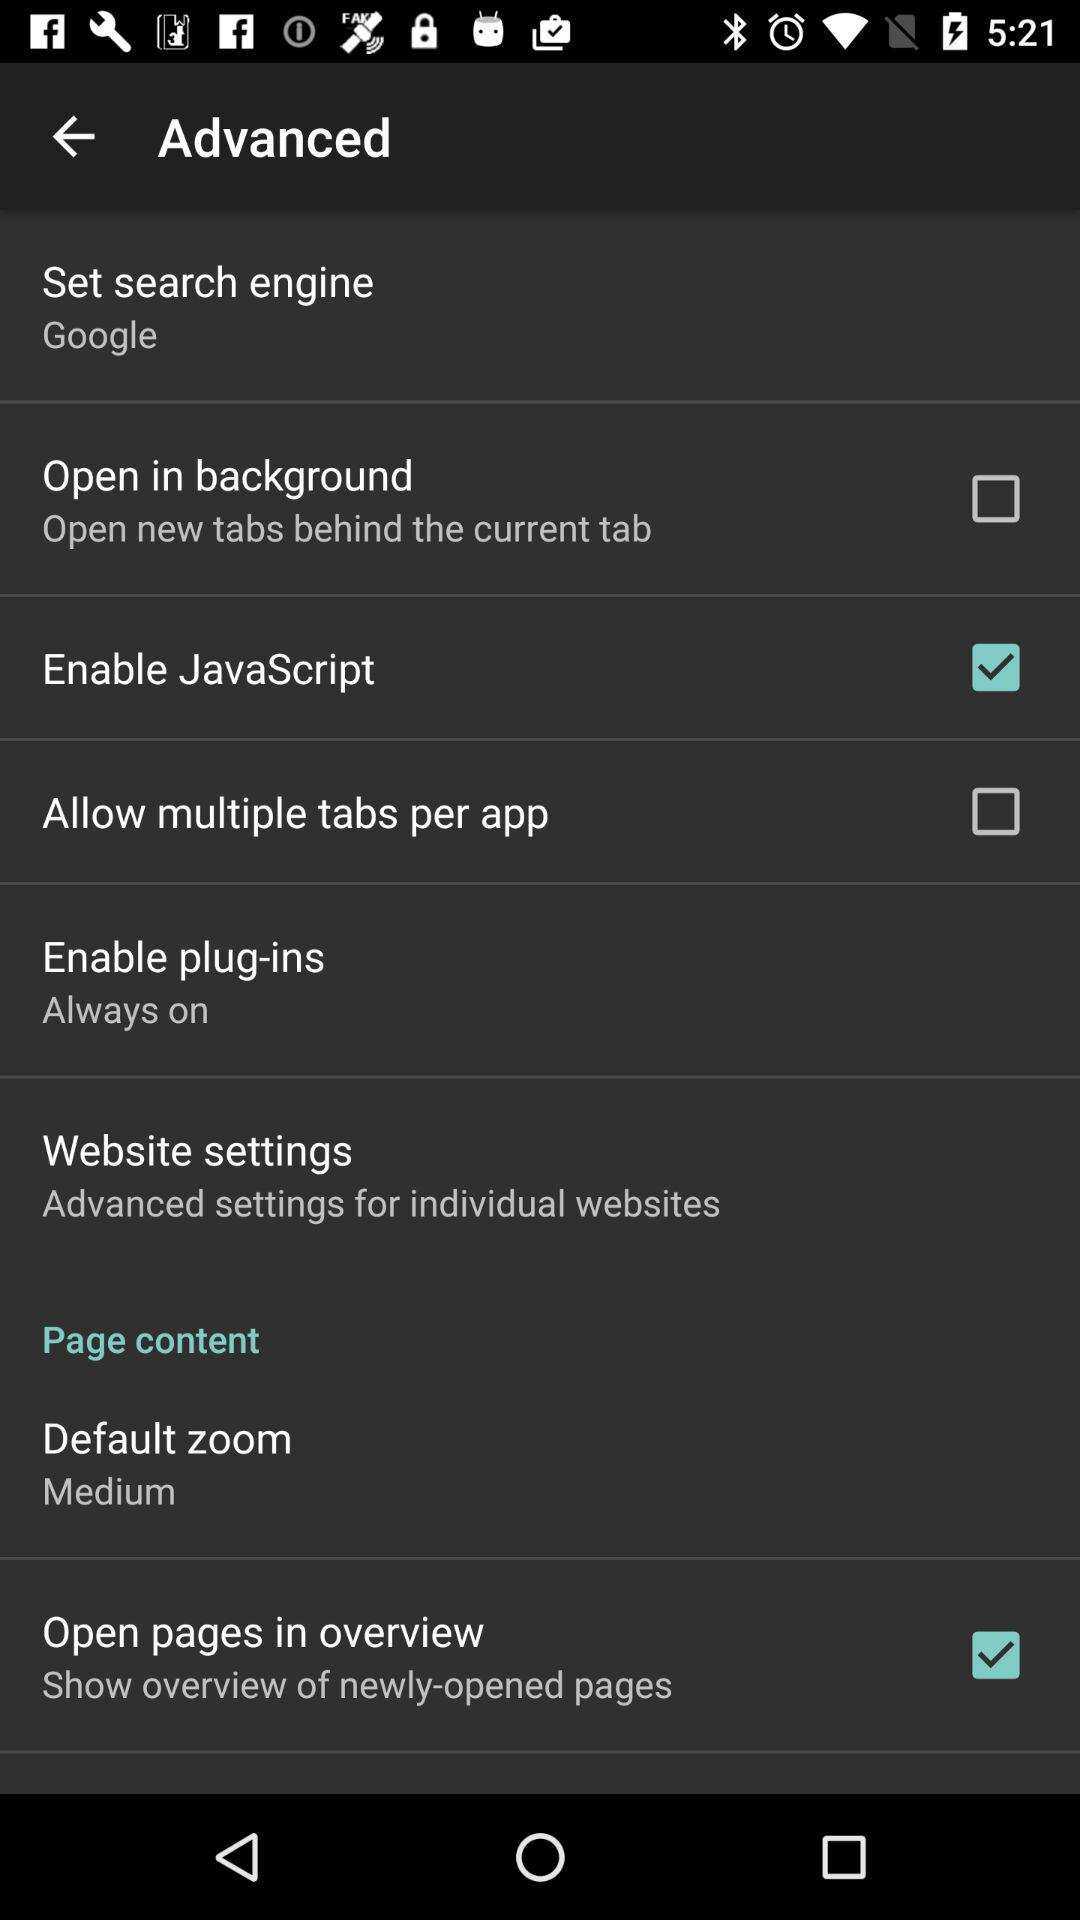What is the setting for "Enable plug-ins"? The setting for "Enable plug-ins" is "Always on". 